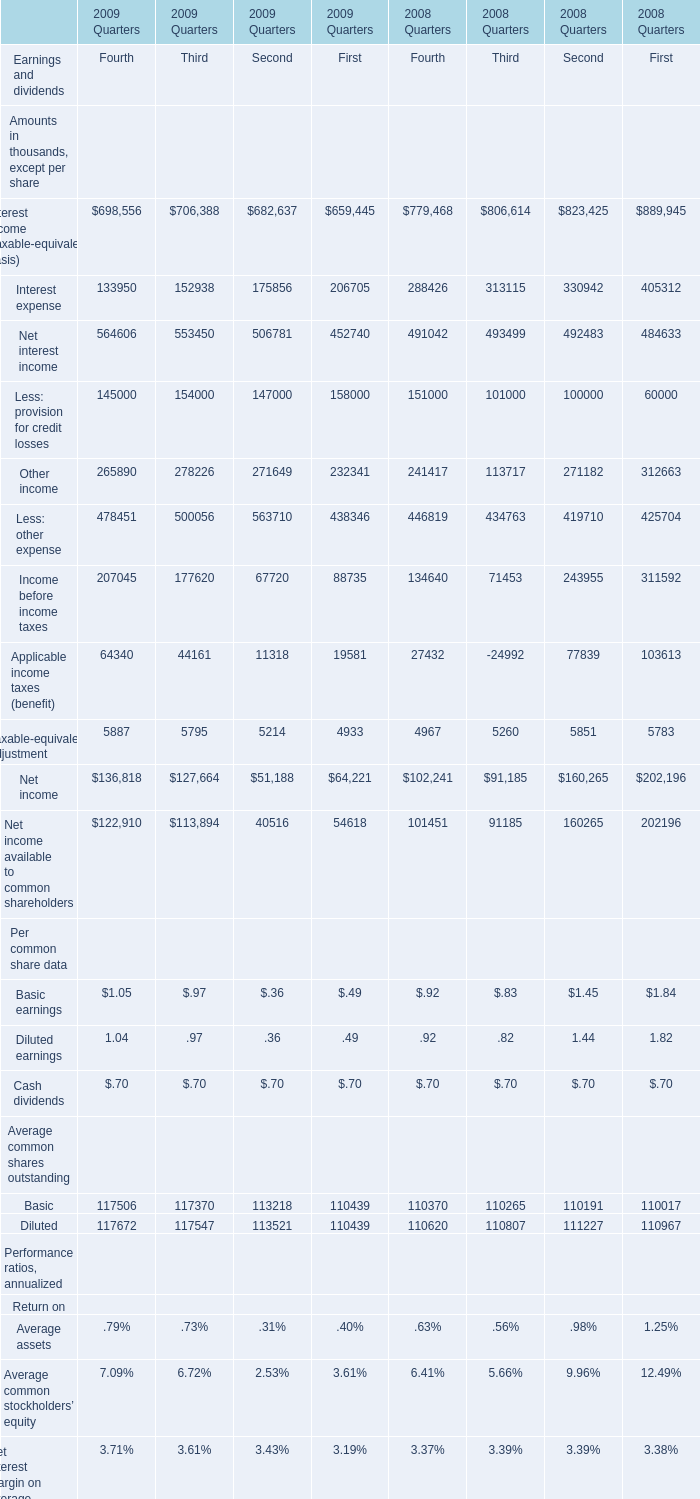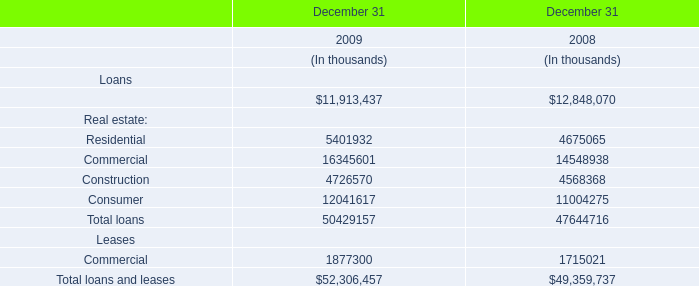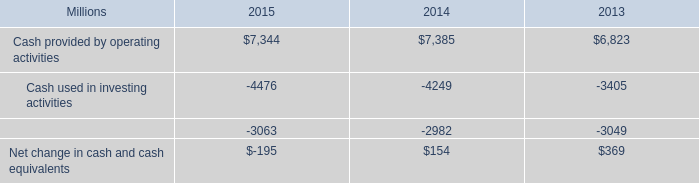What is the total amount of Interest expense of 2008 Quarters First, and Cash provided by operating activities of 2015 ? 
Computations: (405312.0 + 7344.0)
Answer: 412656.0. 